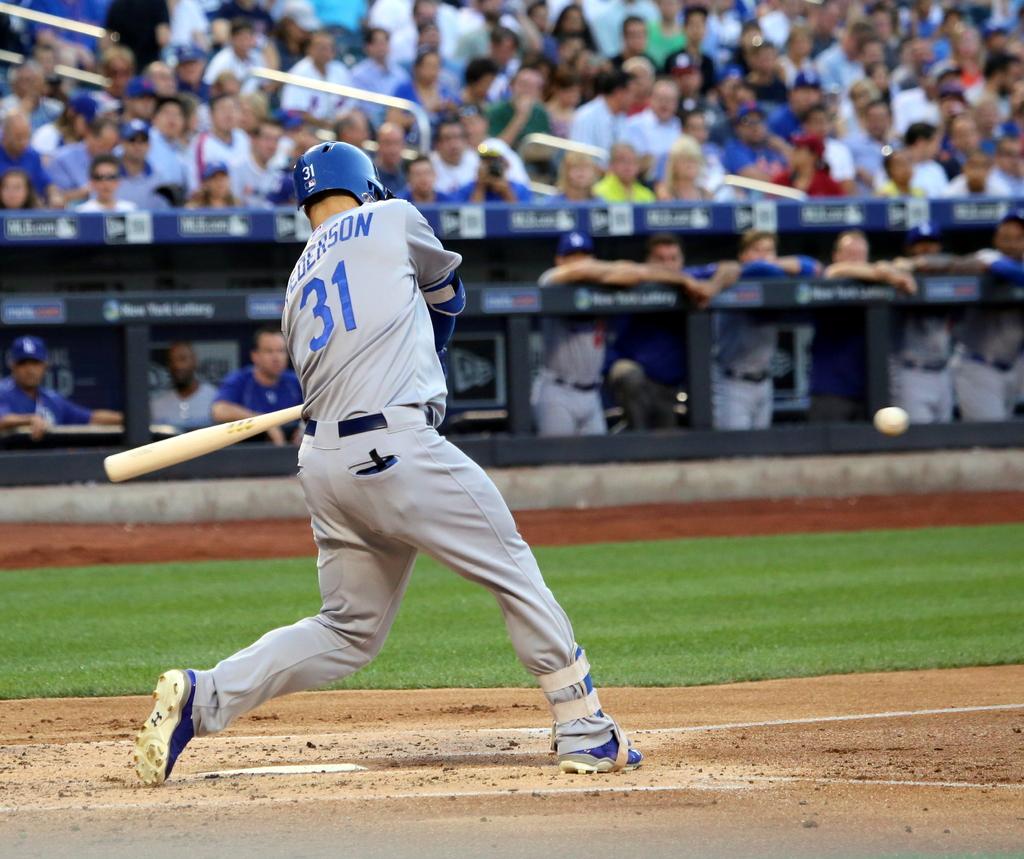What number is the batter?
Your answer should be very brief. 31. Does the helmet have the same number as the jersey?
Your response must be concise. Yes. 